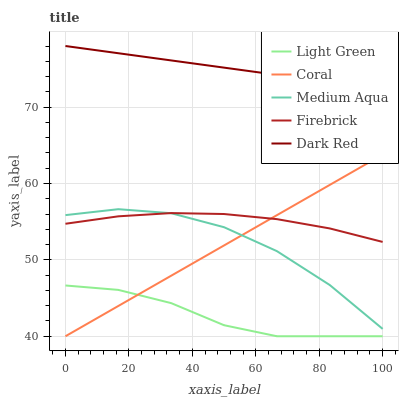Does Coral have the minimum area under the curve?
Answer yes or no. No. Does Coral have the maximum area under the curve?
Answer yes or no. No. Is Coral the smoothest?
Answer yes or no. No. Is Coral the roughest?
Answer yes or no. No. Does Medium Aqua have the lowest value?
Answer yes or no. No. Does Coral have the highest value?
Answer yes or no. No. Is Medium Aqua less than Dark Red?
Answer yes or no. Yes. Is Dark Red greater than Firebrick?
Answer yes or no. Yes. Does Medium Aqua intersect Dark Red?
Answer yes or no. No. 